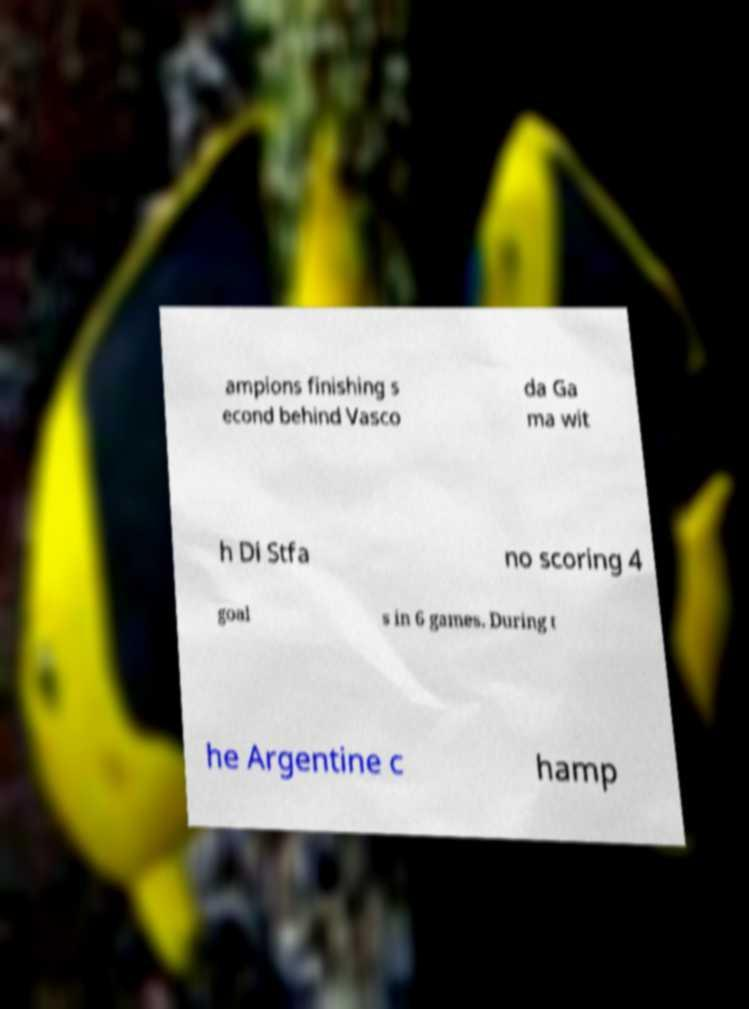What messages or text are displayed in this image? I need them in a readable, typed format. ampions finishing s econd behind Vasco da Ga ma wit h Di Stfa no scoring 4 goal s in 6 games. During t he Argentine c hamp 